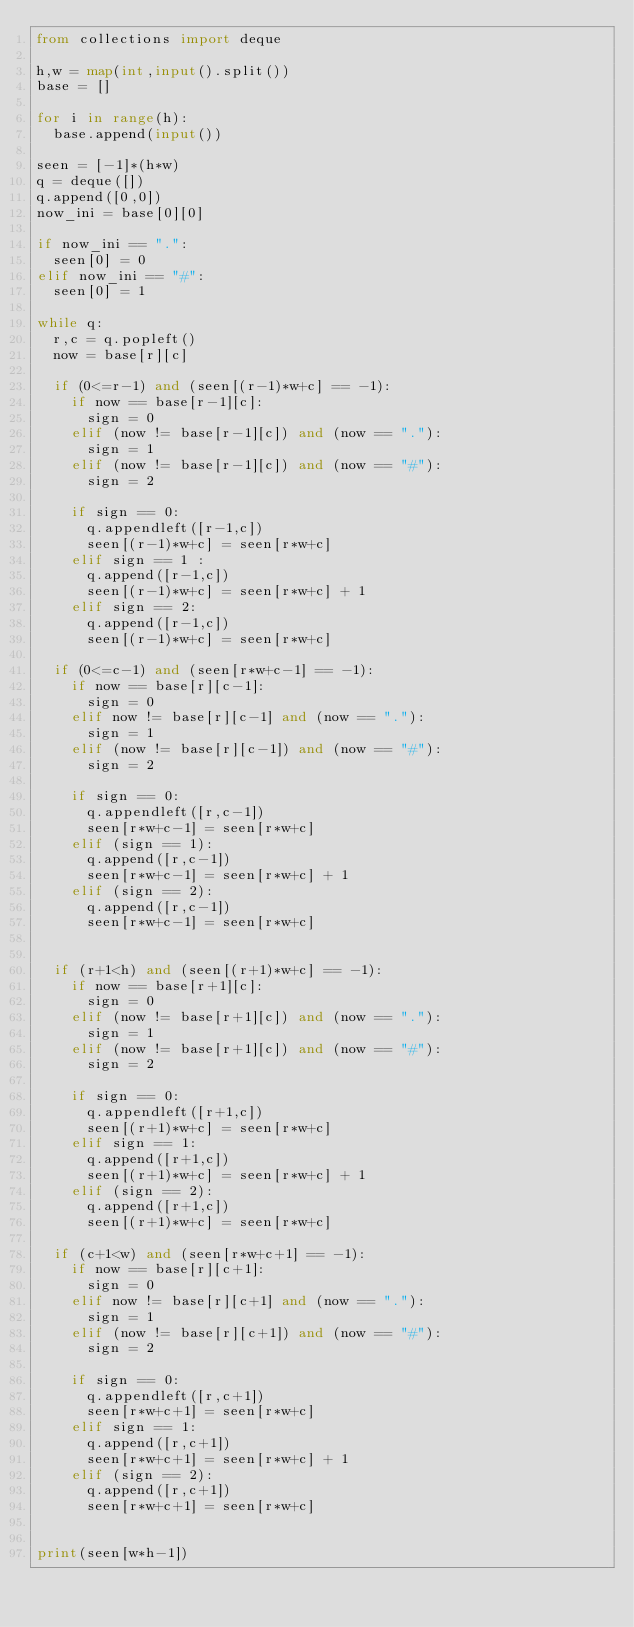<code> <loc_0><loc_0><loc_500><loc_500><_Python_>from collections import deque

h,w = map(int,input().split())
base = []

for i in range(h):
  base.append(input())
  
seen = [-1]*(h*w)
q = deque([])
q.append([0,0])
now_ini = base[0][0]

if now_ini == ".":
  seen[0] = 0
elif now_ini == "#":
  seen[0] = 1

while q:
  r,c = q.popleft()
  now = base[r][c]
  
  if (0<=r-1) and (seen[(r-1)*w+c] == -1):
    if now == base[r-1][c]:
      sign = 0
    elif (now != base[r-1][c]) and (now == "."):
      sign = 1
    elif (now != base[r-1][c]) and (now == "#"):
      sign = 2
      
    if sign == 0:
      q.appendleft([r-1,c])
      seen[(r-1)*w+c] = seen[r*w+c]
    elif sign == 1 :
      q.append([r-1,c])
      seen[(r-1)*w+c] = seen[r*w+c] + 1
    elif sign == 2:
      q.append([r-1,c])
      seen[(r-1)*w+c] = seen[r*w+c]
      
  if (0<=c-1) and (seen[r*w+c-1] == -1):
    if now == base[r][c-1]:
      sign = 0
    elif now != base[r][c-1] and (now == "."):
      sign = 1
    elif (now != base[r][c-1]) and (now == "#"):
      sign = 2
      
    if sign == 0:
      q.appendleft([r,c-1])
      seen[r*w+c-1] = seen[r*w+c]
    elif (sign == 1):
      q.append([r,c-1])
      seen[r*w+c-1] = seen[r*w+c] + 1
    elif (sign == 2):
      q.append([r,c-1])
      seen[r*w+c-1] = seen[r*w+c]
      
      
  if (r+1<h) and (seen[(r+1)*w+c] == -1):
    if now == base[r+1][c]:
      sign = 0
    elif (now != base[r+1][c]) and (now == "."):
      sign = 1
    elif (now != base[r+1][c]) and (now == "#"):
      sign = 2
      
    if sign == 0:
      q.appendleft([r+1,c])
      seen[(r+1)*w+c] = seen[r*w+c]
    elif sign == 1:
      q.append([r+1,c])
      seen[(r+1)*w+c] = seen[r*w+c] + 1
    elif (sign == 2):
      q.append([r+1,c])
      seen[(r+1)*w+c] = seen[r*w+c]
      
  if (c+1<w) and (seen[r*w+c+1] == -1):
    if now == base[r][c+1]:
      sign = 0
    elif now != base[r][c+1] and (now == "."):
      sign = 1
    elif (now != base[r][c+1]) and (now == "#"):
      sign = 2
      
    if sign == 0:
      q.appendleft([r,c+1])
      seen[r*w+c+1] = seen[r*w+c]
    elif sign == 1:
      q.append([r,c+1])
      seen[r*w+c+1] = seen[r*w+c] + 1
    elif (sign == 2):
      q.append([r,c+1])
      seen[r*w+c+1] = seen[r*w+c]
      
      
print(seen[w*h-1])</code> 